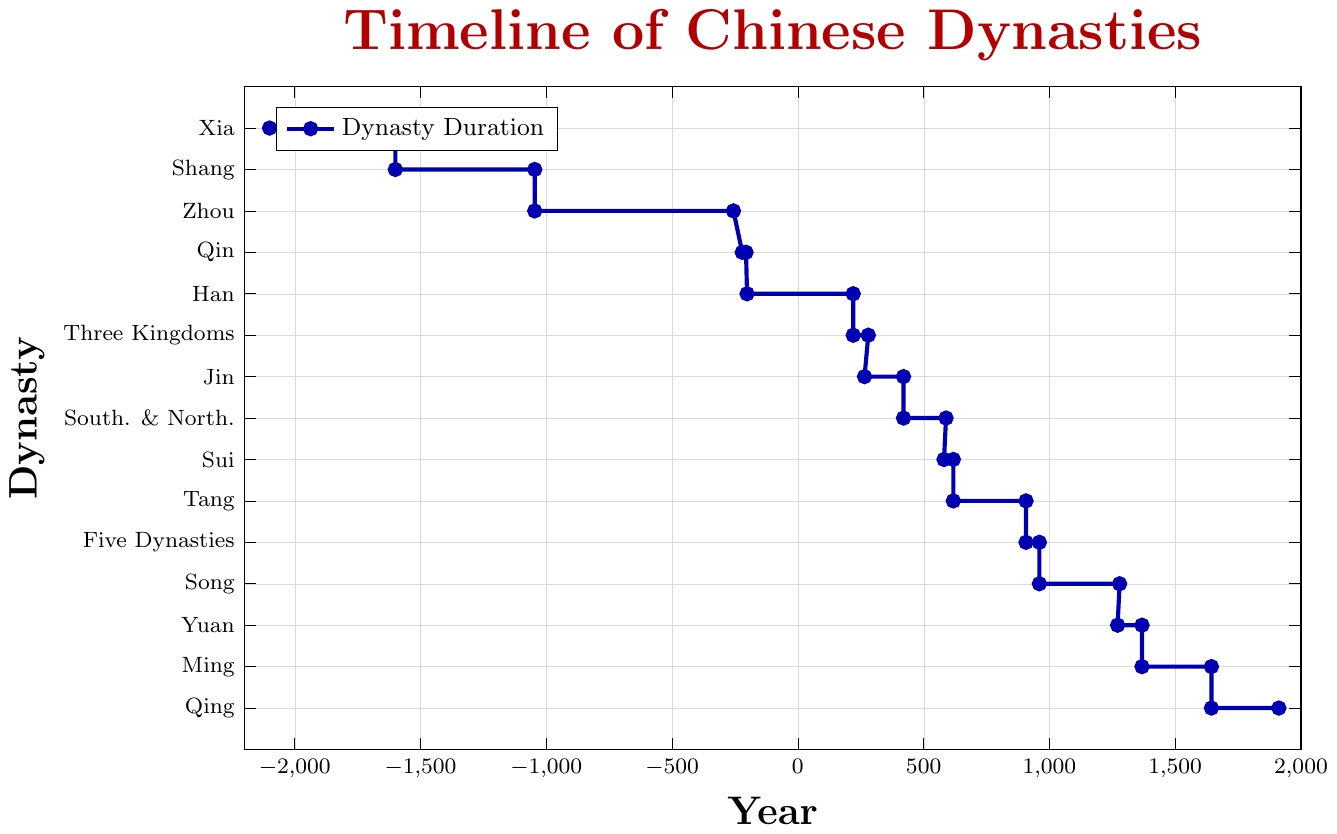Which dynasty lasted the longest? Comparing the lengths of all visual line segments representing each dynasty, the Zhou dynasty spans from -1046 to -256 BCE, which is the longest duration.
Answer: Zhou Which dynasty immediately followed the Han dynasty? Observing the timeline, the Three Kingdoms (220-280 CE) starts right after the Han dynasty (202 BCE-220 CE).
Answer: Three Kingdoms How long did the Tang dynasty last? To calculate the duration, subtract the start year from the end year: 907 - 618 = 289 years.
Answer: 289 years Which lasted longer, the Ming dynasty or the Yuan dynasty? Compare the lengths of the Ming dynasty (1368-1644) to the Yuan dynasty (1271-1368): The Ming dynasty lasted 1644-1368 = 276 years, while the Yuan dynasty lasted 1368-1271 = 97 years.
Answer: Ming How many years did the Five Dynasties and Ten Kingdoms period last? Subtract the start year from the end year: 960 - 907 = 53 years.
Answer: 53 years What is the last dynasty represented on the timeline? Looking at the end of the timeline, the last dynasty shown is the Qing dynasty, which ended in 1912 CE.
Answer: Qing Which was shorter, the period of the Qin dynasty or the Sui dynasty? The Qin dynasty (221-206 BCE) lasted 15 years, and the Sui dynasty (581-618 CE) lasted 37 years. The Qin dynasty was shorter.
Answer: Qin What dynasties spanned both BCE and CE years? From the timeline, the Han (202 BCE-220 CE) is the only dynasty that spans both BCE and CE years.
Answer: Han Which dynasty came before the Zhou dynasty? Observing the timeline, the Shang dynasty (1600-1046 BCE) came before the Zhou dynasty (1046-256 BCE).
Answer: Shang How many years was the gap between the end of the Southern and Northern Dynasties and the start of the Tang dynasty? The Southern and Northern Dynasties ended in 589 CE, and the Tang dynasty started in 618 CE. The gap is 618 - 589 = 29 years.
Answer: 29 years 